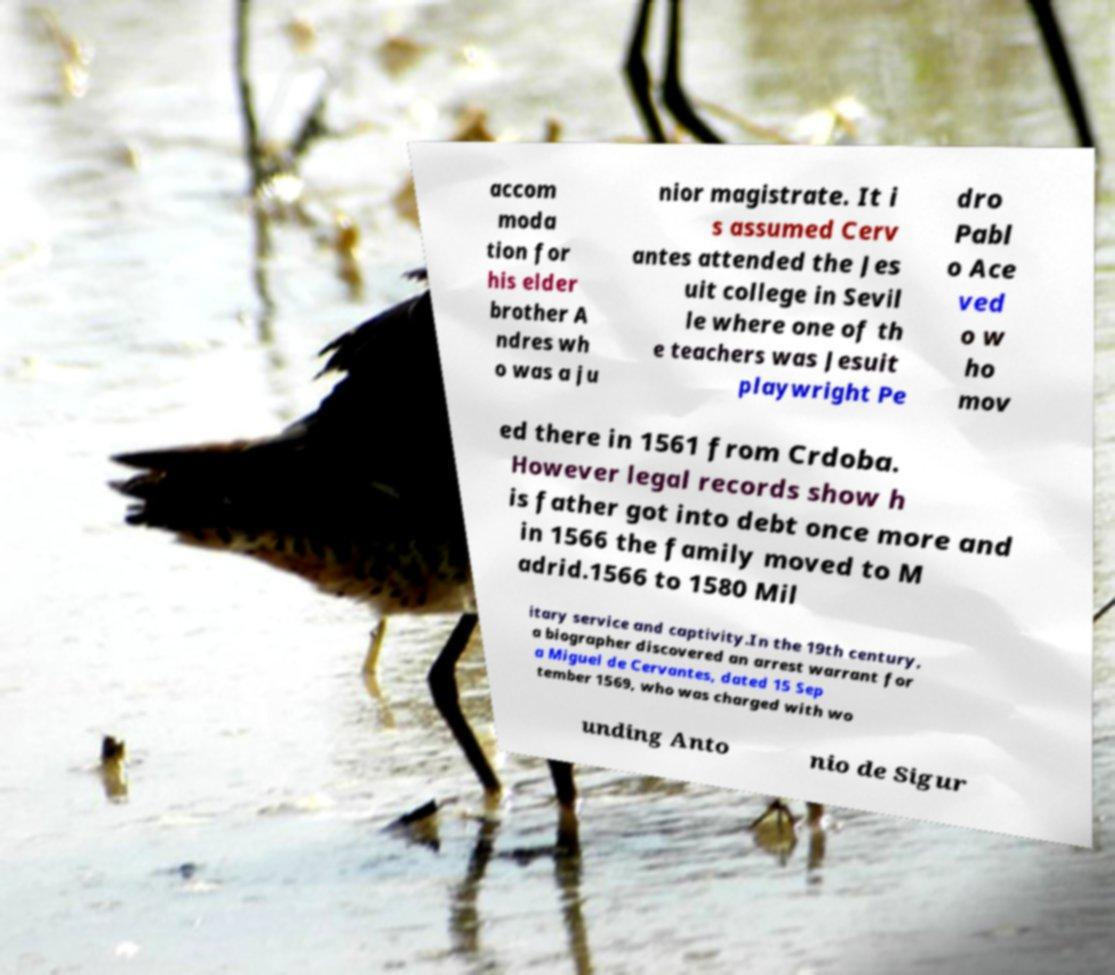There's text embedded in this image that I need extracted. Can you transcribe it verbatim? accom moda tion for his elder brother A ndres wh o was a ju nior magistrate. It i s assumed Cerv antes attended the Jes uit college in Sevil le where one of th e teachers was Jesuit playwright Pe dro Pabl o Ace ved o w ho mov ed there in 1561 from Crdoba. However legal records show h is father got into debt once more and in 1566 the family moved to M adrid.1566 to 1580 Mil itary service and captivity.In the 19th century, a biographer discovered an arrest warrant for a Miguel de Cervantes, dated 15 Sep tember 1569, who was charged with wo unding Anto nio de Sigur 